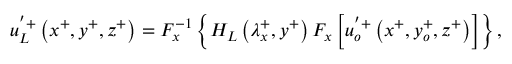Convert formula to latex. <formula><loc_0><loc_0><loc_500><loc_500>u _ { L } ^ { ^ { \prime } + } \left ( x ^ { + } , y ^ { + } , z ^ { + } \right ) = F _ { x } ^ { - 1 } \left \{ H _ { L } \left ( \lambda _ { x } ^ { + } , y ^ { + } \right ) F _ { x } \left [ u _ { o } ^ { ^ { \prime } + } \left ( x ^ { + } , y _ { o } ^ { + } , z ^ { + } \right ) \right ] \right \} ,</formula> 